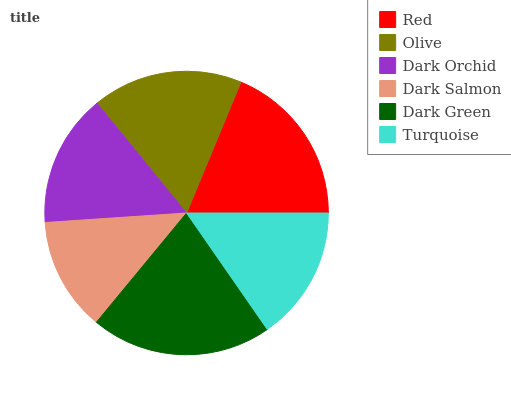Is Dark Salmon the minimum?
Answer yes or no. Yes. Is Dark Green the maximum?
Answer yes or no. Yes. Is Olive the minimum?
Answer yes or no. No. Is Olive the maximum?
Answer yes or no. No. Is Red greater than Olive?
Answer yes or no. Yes. Is Olive less than Red?
Answer yes or no. Yes. Is Olive greater than Red?
Answer yes or no. No. Is Red less than Olive?
Answer yes or no. No. Is Olive the high median?
Answer yes or no. Yes. Is Turquoise the low median?
Answer yes or no. Yes. Is Dark Salmon the high median?
Answer yes or no. No. Is Olive the low median?
Answer yes or no. No. 